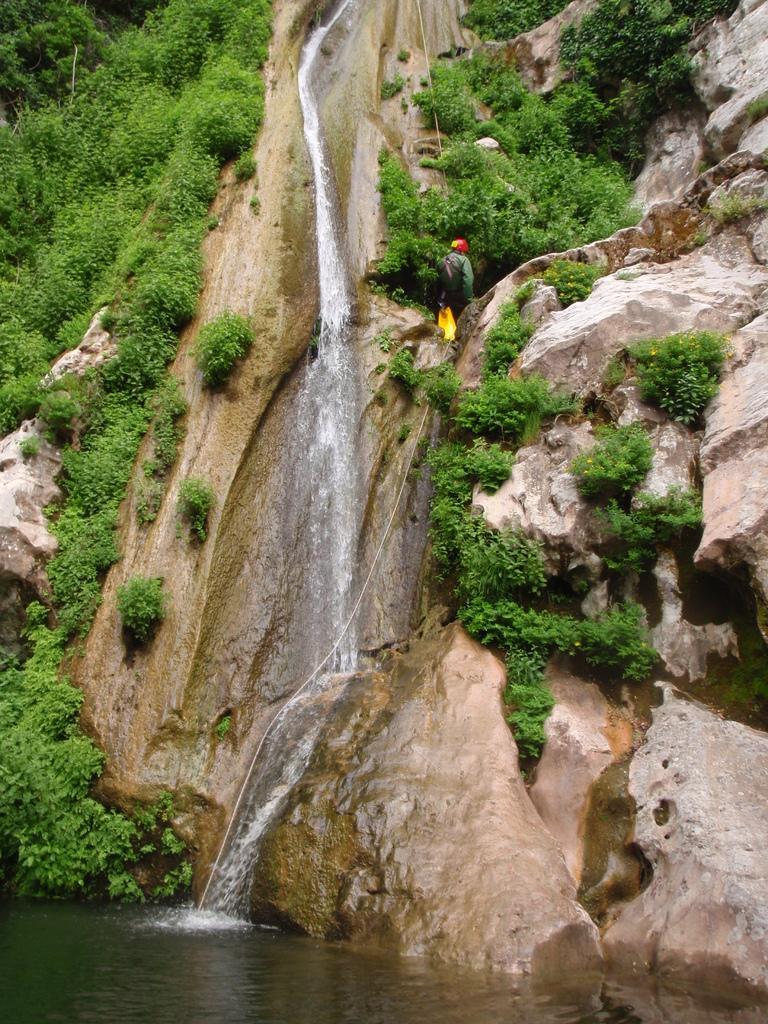In one or two sentences, can you explain what this image depicts? This is a water fall, in the down it is water, there are trees on this hill. 